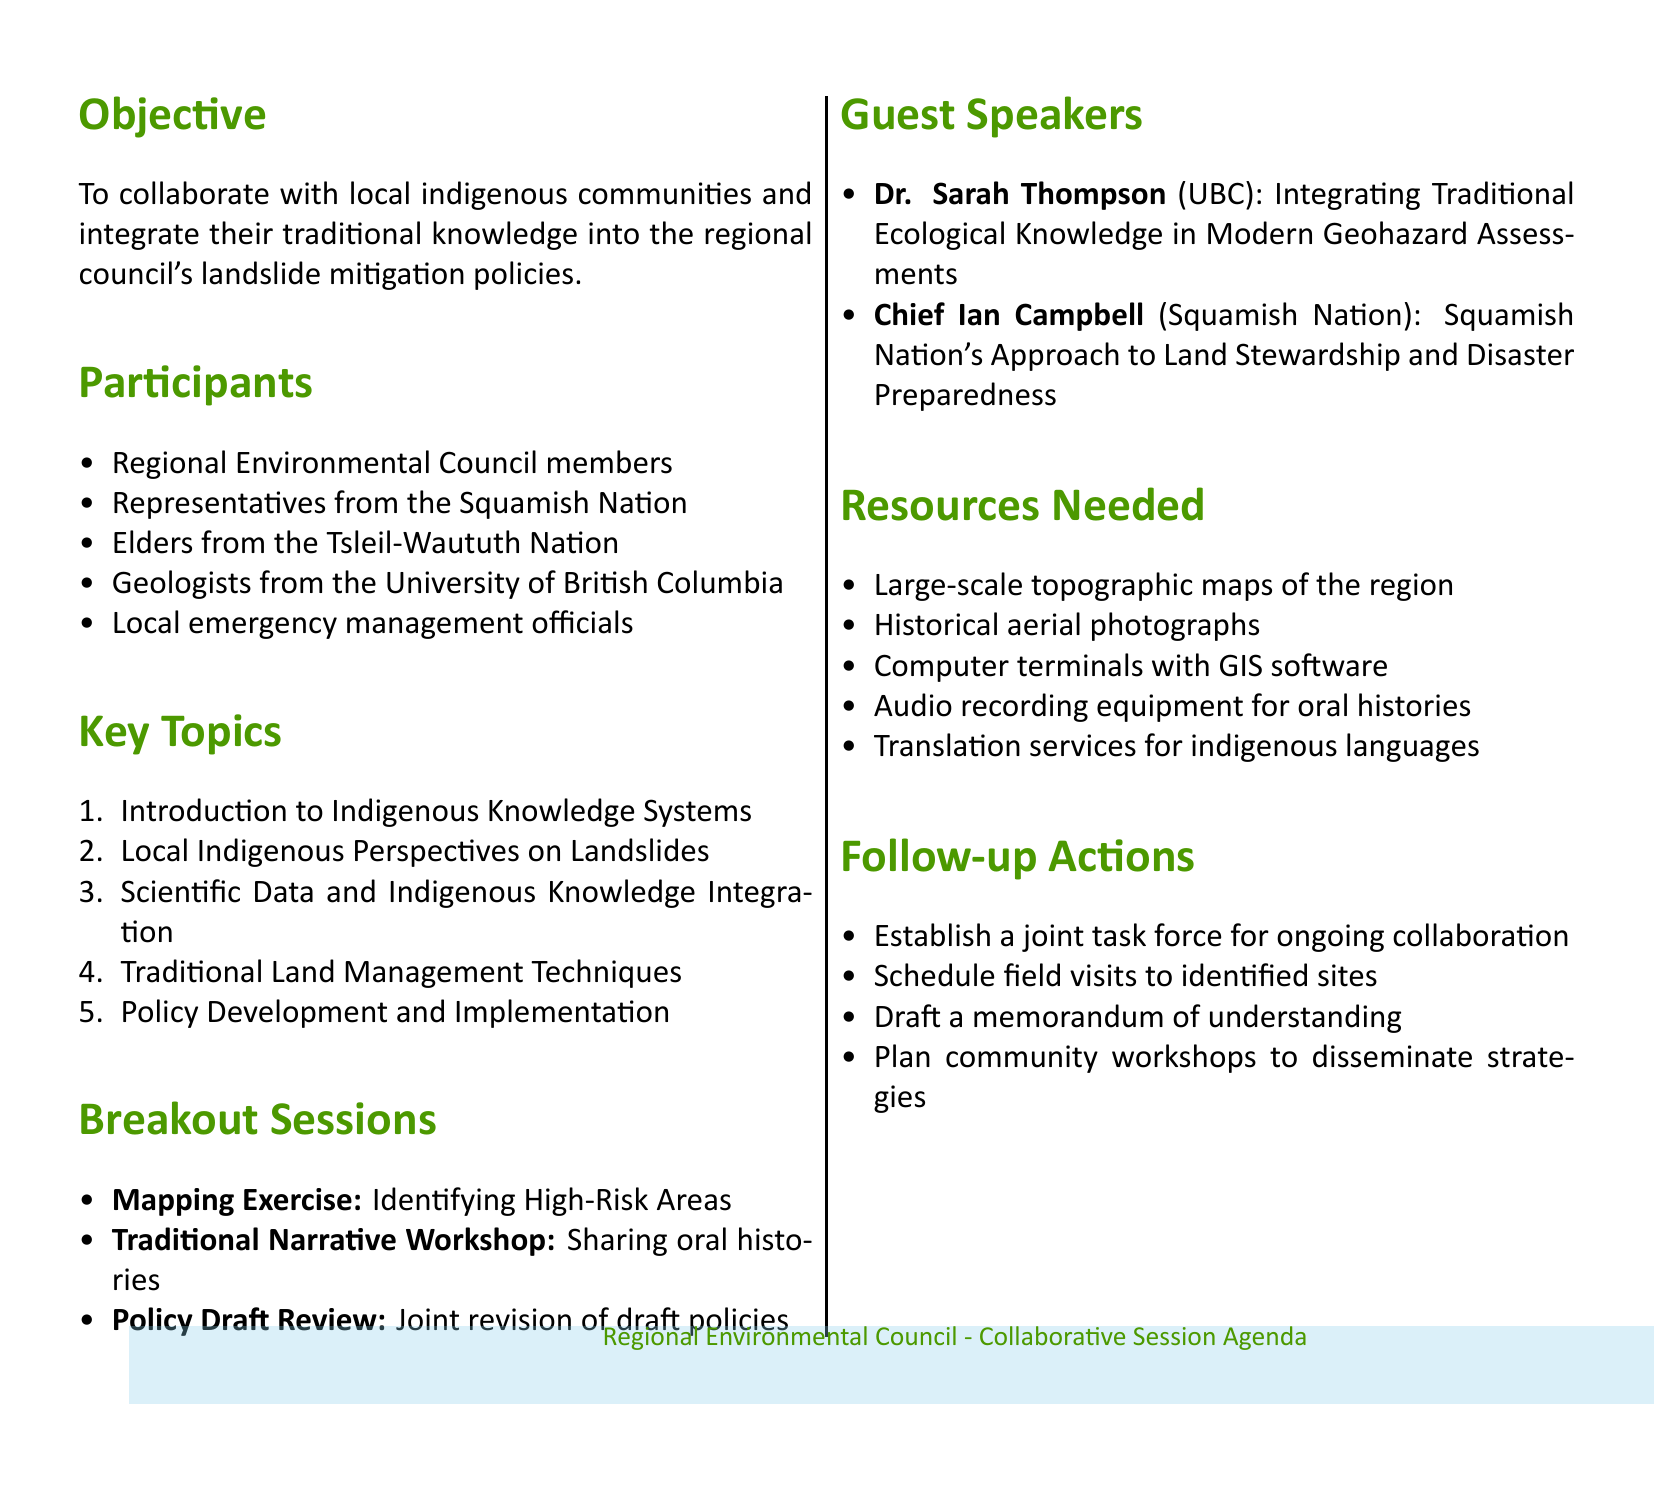What is the session title? The session title is mentioned at the beginning of the document, highlighting the main focus of the agenda.
Answer: Incorporating Traditional Knowledge into Landslide Mitigation Strategies Who is one of the guest speakers? The document lists guest speakers, indicating their names and affiliations.
Answer: Dr. Sarah Thompson What is one of the key topics? The document includes several key topics under which discussions will take place during the session.
Answer: Introduction to Indigenous Knowledge Systems What type of session is the "Mapping Exercise"? The document describes the nature and purpose of various breakout sessions.
Answer: Collaborative mapping session How many participants are listed? The document enumerates different participant groups involved in the session, providing a specific count.
Answer: Five What is a follow-up action mentioned? The document outlines follow-up actions to be taken after the session, indicating the ongoing process.
Answer: Establish a joint task force for ongoing collaboration What importance is given to oral histories? The document highlights the significance of oral histories in relation to indigenous knowledge and environmental changes.
Answer: Understanding long-term environmental changes What resource is needed for capturing oral histories? The document specifies resources required for the session, including those related to collecting indigenous narratives.
Answer: Audio recording equipment for capturing oral histories 